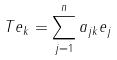<formula> <loc_0><loc_0><loc_500><loc_500>T e _ { k } = \sum _ { j = 1 } ^ { n } a _ { j k } e _ { j }</formula> 